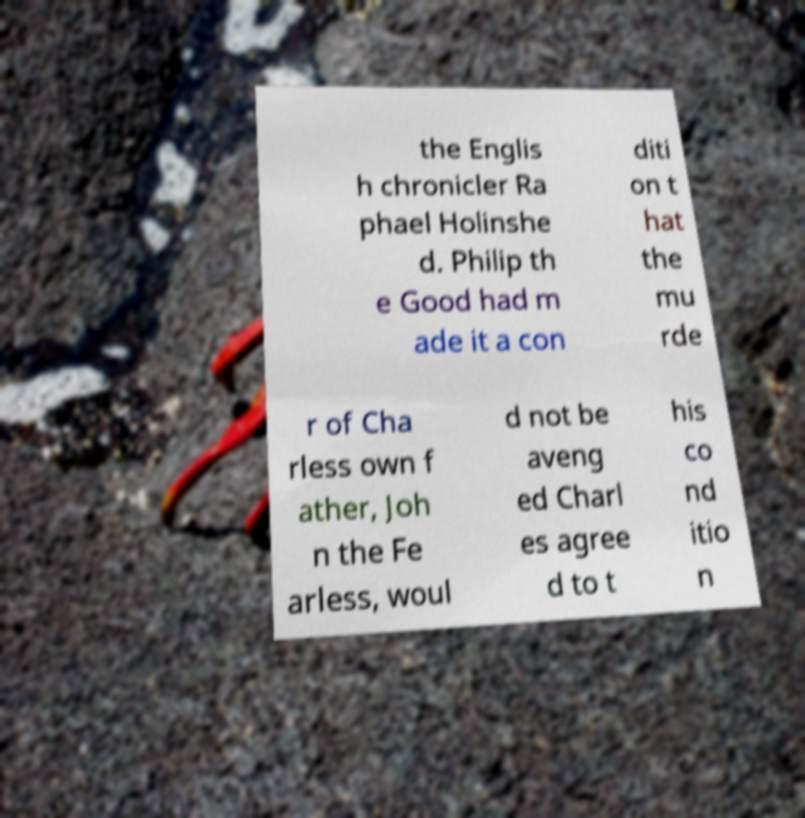Can you accurately transcribe the text from the provided image for me? the Englis h chronicler Ra phael Holinshe d. Philip th e Good had m ade it a con diti on t hat the mu rde r of Cha rless own f ather, Joh n the Fe arless, woul d not be aveng ed Charl es agree d to t his co nd itio n 